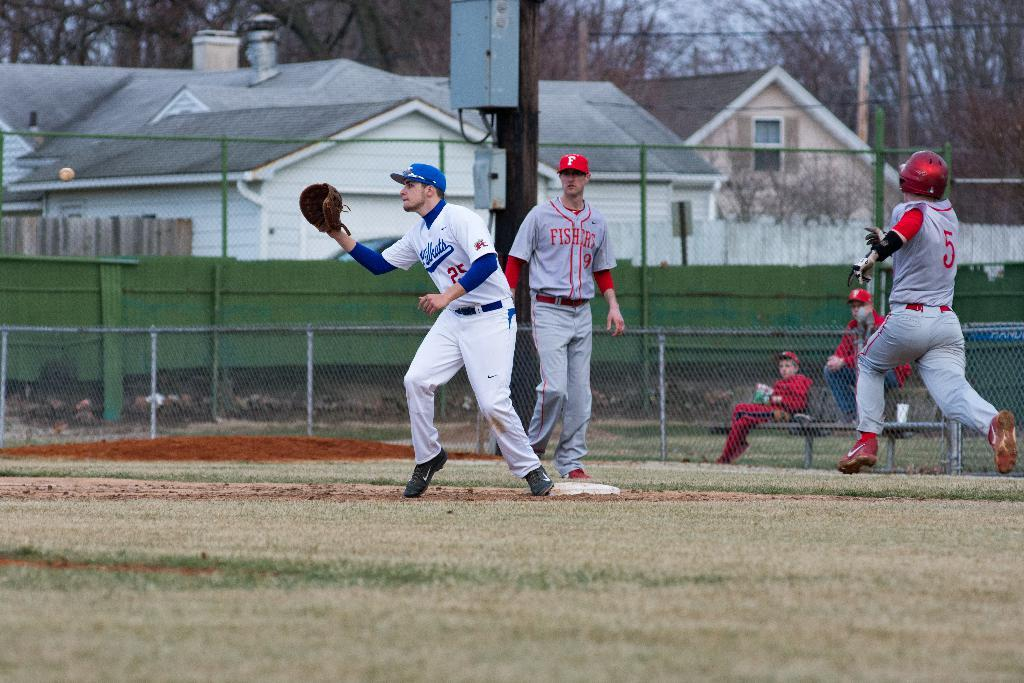<image>
Write a terse but informative summary of the picture. A baseball player for the Fishers is walking behind another baseball player, from another team, who is catching a ball. 